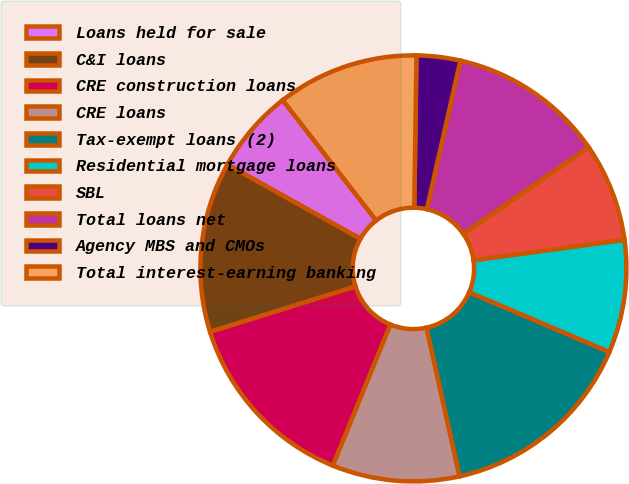Convert chart to OTSL. <chart><loc_0><loc_0><loc_500><loc_500><pie_chart><fcel>Loans held for sale<fcel>C&I loans<fcel>CRE construction loans<fcel>CRE loans<fcel>Tax-exempt loans (2)<fcel>Residential mortgage loans<fcel>SBL<fcel>Total loans net<fcel>Agency MBS and CMOs<fcel>Total interest-earning banking<nl><fcel>6.39%<fcel>12.92%<fcel>14.01%<fcel>9.65%<fcel>15.1%<fcel>8.57%<fcel>7.48%<fcel>11.83%<fcel>3.31%<fcel>10.74%<nl></chart> 